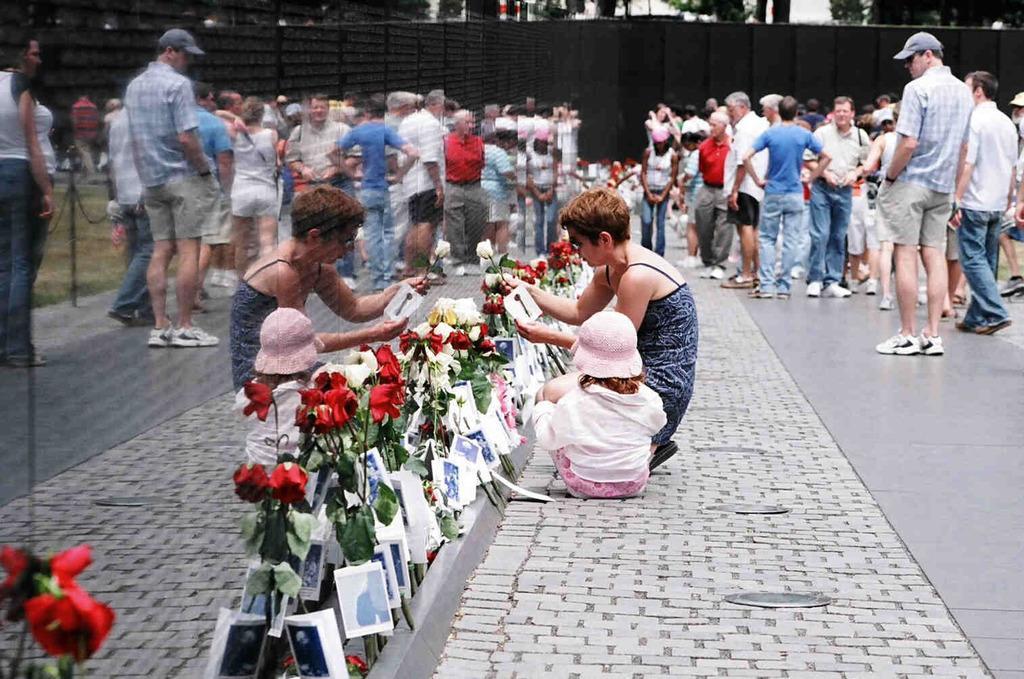Please provide a concise description of this image. On the right side of the image, we can see a group of people are standing on the platform. In the middle we can see a woman and kid. A woman is holding a card and flower. Background there is a wall. On the left side, we can see a few reflections on the wall, photography, flowers with stems and leaves. 